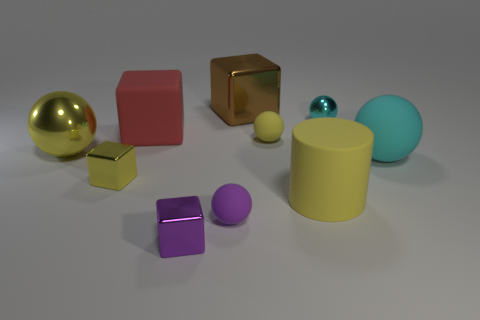Subtract 1 blocks. How many blocks are left? 3 Subtract all yellow shiny blocks. How many blocks are left? 3 Subtract all brown blocks. How many blocks are left? 3 Subtract all cyan blocks. Subtract all red spheres. How many blocks are left? 4 Subtract 1 yellow cubes. How many objects are left? 9 Subtract all cylinders. How many objects are left? 9 Subtract all big brown blocks. Subtract all big red cubes. How many objects are left? 8 Add 7 tiny yellow metal blocks. How many tiny yellow metal blocks are left? 8 Add 6 tiny gray metal balls. How many tiny gray metal balls exist? 6 